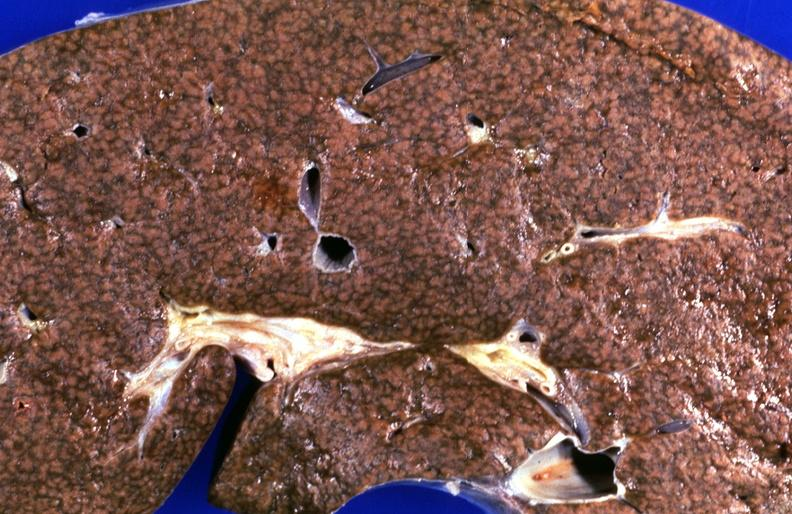what is present?
Answer the question using a single word or phrase. Hepatobiliary 